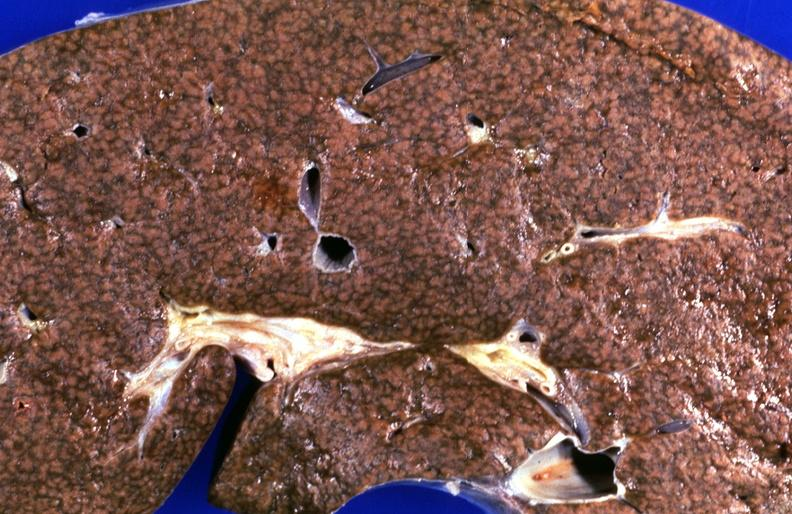what is present?
Answer the question using a single word or phrase. Hepatobiliary 